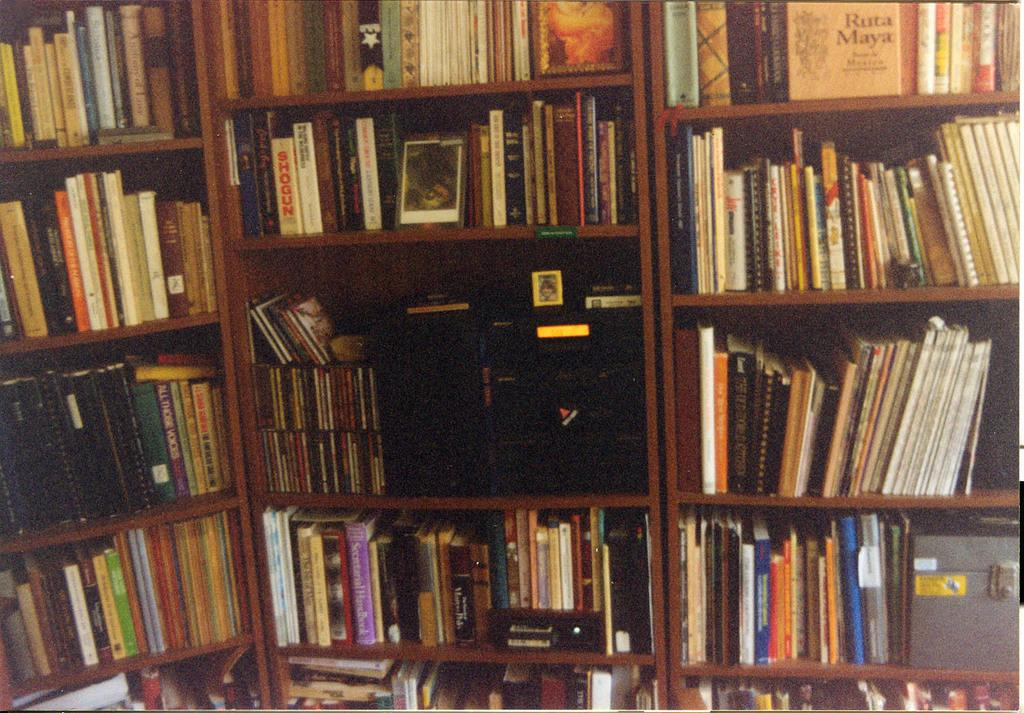What type of furniture is visible in the image? There are cupboards with racks in the image. What items can be seen on the racks? There are books and a box on the racks. What is the color of the object on the racks? There is a black color object on the racks. What is the price of the toys on the racks? There are no toys present in the image, so it is not possible to determine their price. 